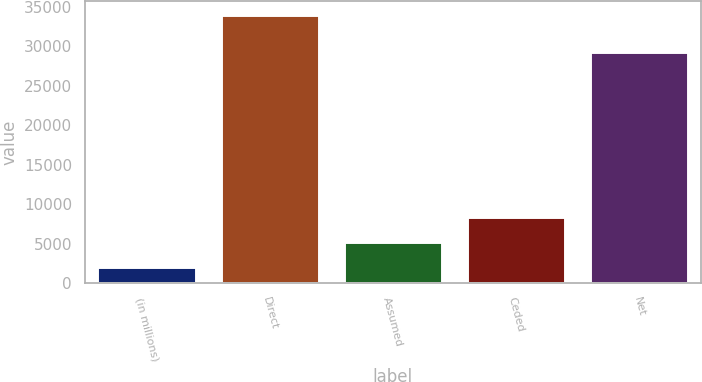<chart> <loc_0><loc_0><loc_500><loc_500><bar_chart><fcel>(in millions)<fcel>Direct<fcel>Assumed<fcel>Ceded<fcel>Net<nl><fcel>2016<fcel>33970<fcel>5211.4<fcel>8406.8<fcel>29233<nl></chart> 